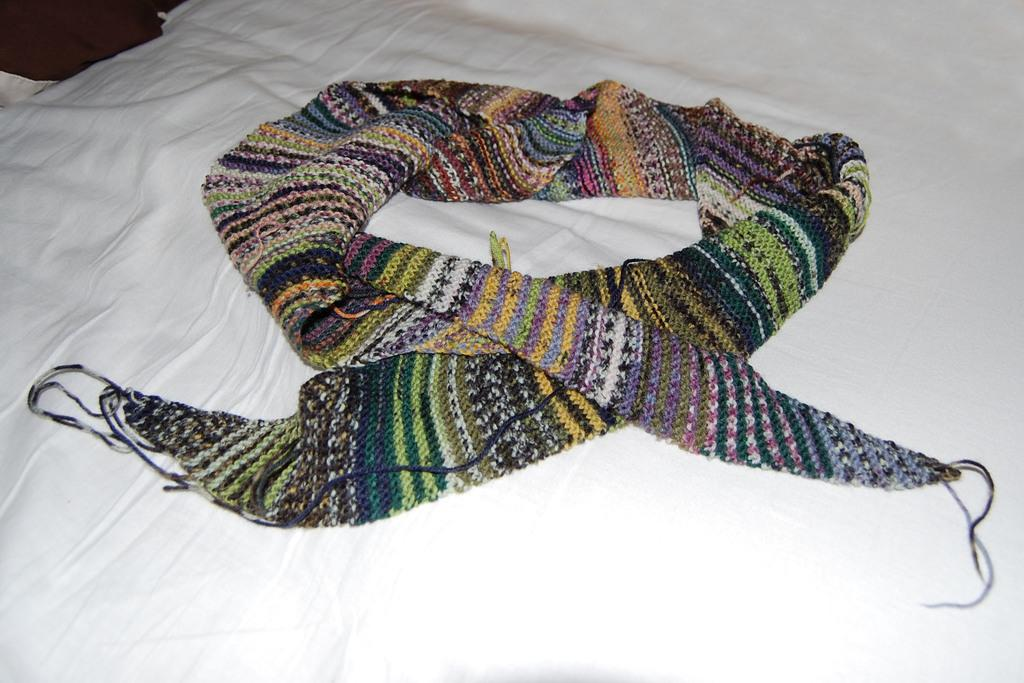What is the primary color of the cloth in the image? The primary color of the cloth in the image is white. What is placed on the white cloth? There is a colorful woolen scarf on the white cloth. What type of mouth can be seen on the woolen scarf in the image? There is no mouth present on the woolen scarf in the image. What form of transportation is used by the woolen scarf in the image? The woolen scarf is an inanimate object and does not use any form of transportation. 